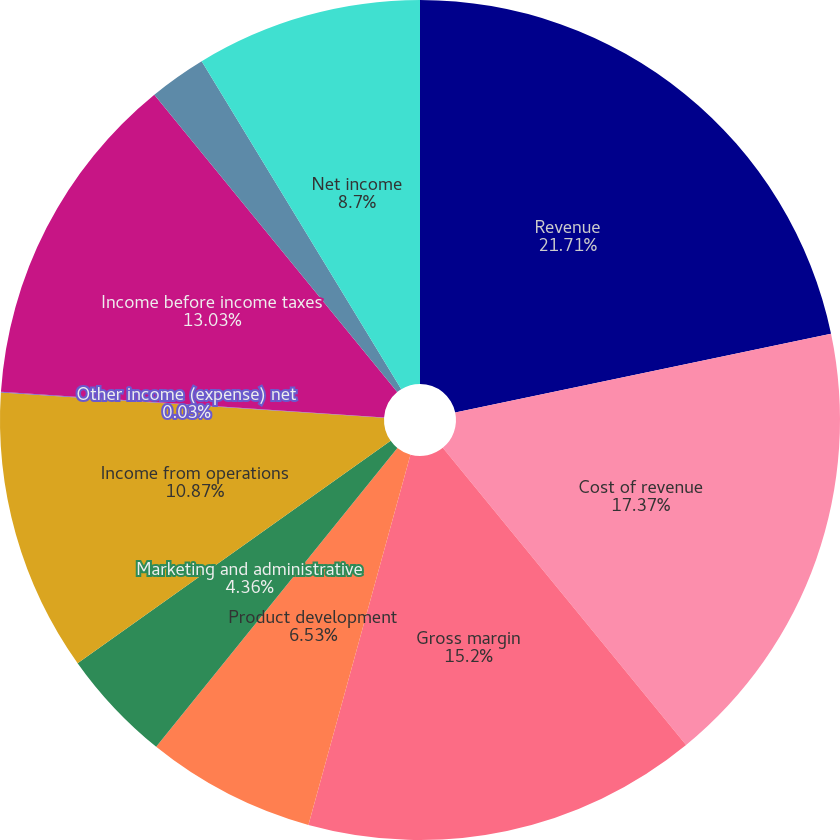<chart> <loc_0><loc_0><loc_500><loc_500><pie_chart><fcel>Revenue<fcel>Cost of revenue<fcel>Gross margin<fcel>Product development<fcel>Marketing and administrative<fcel>Income from operations<fcel>Other income (expense) net<fcel>Income before income taxes<fcel>Provision for (benefit from)<fcel>Net income<nl><fcel>21.71%<fcel>17.37%<fcel>15.2%<fcel>6.53%<fcel>4.36%<fcel>10.87%<fcel>0.03%<fcel>13.03%<fcel>2.2%<fcel>8.7%<nl></chart> 